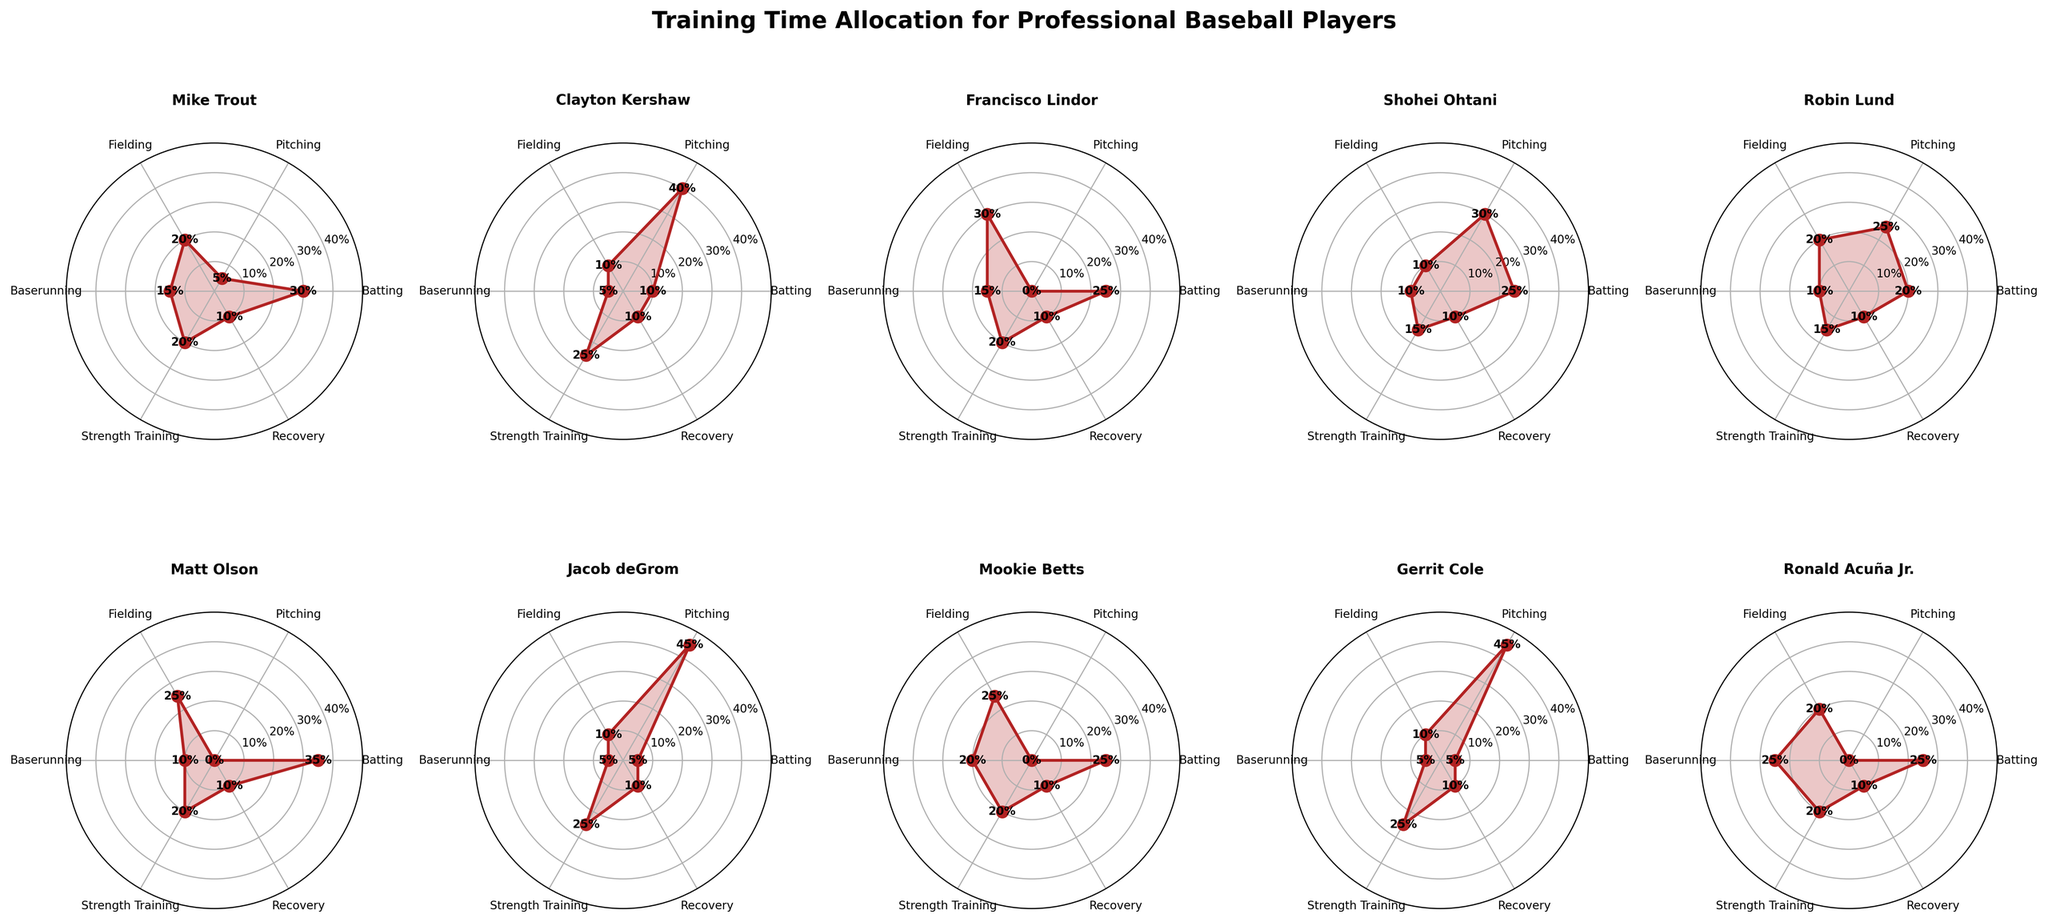What's the title of the figure? The title can be found at the top of the figure which summarizes the data visualization contents.
Answer: Training Time Allocation for Professional Baseball Players How many skills are evaluated in the figure? Count the number of unique skill labels displayed in each subplot.
Answer: 6 Which player allocates the most time to batting? Look for the subplot with the highest value on the 'Batting' skill axis.
Answer: Matt Olson What's the average time allocation for pitching across all players? Add up the pitching times for all players and divide by the number of players (5+40+0+30+25+0+45+0+45+0)/10.
Answer: 19 Which skill has the lowest percentage for Shohei Ohtani? In Shohei Ohtani's subplot, identify the skill with the minimum value.
Answer: Baserunning Compare Mike Trout and Jacob deGrom: who spends more time on strength training? Look at the strength training values in both subplots and compare them. Mike Trout: 20%, Jacob deGrom: 25%.
Answer: Jacob deGrom How does Ronald Acuña Jr. allocate his time to baserunning compared to Francisco Lindor? Compare the values in the baserunning skill in their respective subplots. Ronald Acuña Jr.: 25%, Francisco Lindor: 15%.
Answer: Ronald Acuña Jr What is the combined time allocated to recovery for all players? Add the recovery times for all players: 10+10+10+10+10+10+10+10+10+10.
Answer: 100 Which player has the most balanced training time allocation across all skills? A balanced allocation would show similar values across all skills. Visually inspect subplots for even distribution.
Answer: Robin Lund What is the difference in fielding time allocation between Clayton Kershaw and Gerrit Cole? Subtract the fielding value of Clayton Kershaw from that of Gerrit Cole (10-10).
Answer: 0 